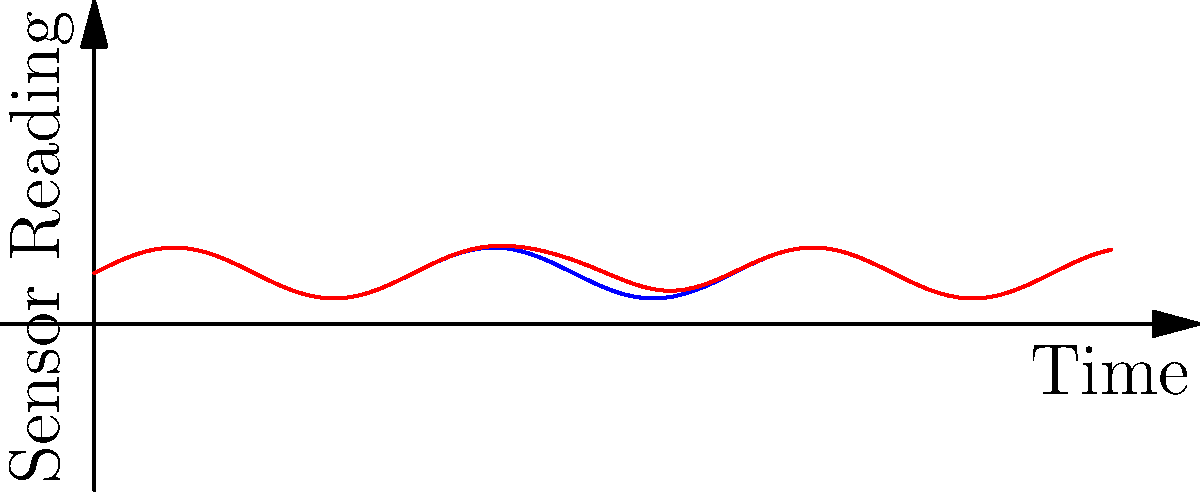As an ISS client considering diversifying service providers, you're evaluating anomaly detection methods for spacecraft sensor data. Given the time-series data shown in the graph, which statistical technique would be most appropriate for detecting the anomaly present in the red curve? To determine the most appropriate statistical technique for detecting the anomaly in the red curve, let's analyze the characteristics of the data:

1. The blue curve represents the normal pattern of the sensor readings, which follows a sinusoidal pattern.
2. The red curve shows a deviation from this normal pattern, with a sudden spike around the midpoint of the time series.
3. The anomaly appears to be localized and temporary, not affecting the overall trend of the data.

Given these observations, we can consider the following techniques:

a) Moving Average: This method would smooth out short-term fluctuations but might not be sensitive enough to detect a brief anomaly.

b) Exponential Smoothing: Similar to moving average, it might not capture sudden, short-lived anomalies effectively.

c) Control Charts: These are designed to detect sustained shifts in the process mean or variance, which is not the case here.

d) Seasonal Decomposition: This would be useful for identifying seasonal patterns, but the anomaly here is not seasonal.

e) Z-score Method: This compares each data point to the mean and standard deviation of the entire series, which might not be effective for detecting localized anomalies.

f) $\textbf{Kernel Density Estimation (KDE)}$: This non-parametric method estimates the probability density function of the data. It can effectively identify regions of low probability, which correspond to anomalies.

Given the nature of the anomaly (sudden, localized spike) and the overall pattern of the data, Kernel Density Estimation (KDE) would be the most appropriate technique. KDE can capture the underlying distribution of the normal data (blue curve) and identify points that have a low probability of occurring under this distribution (the spike in the red curve).
Answer: Kernel Density Estimation (KDE) 